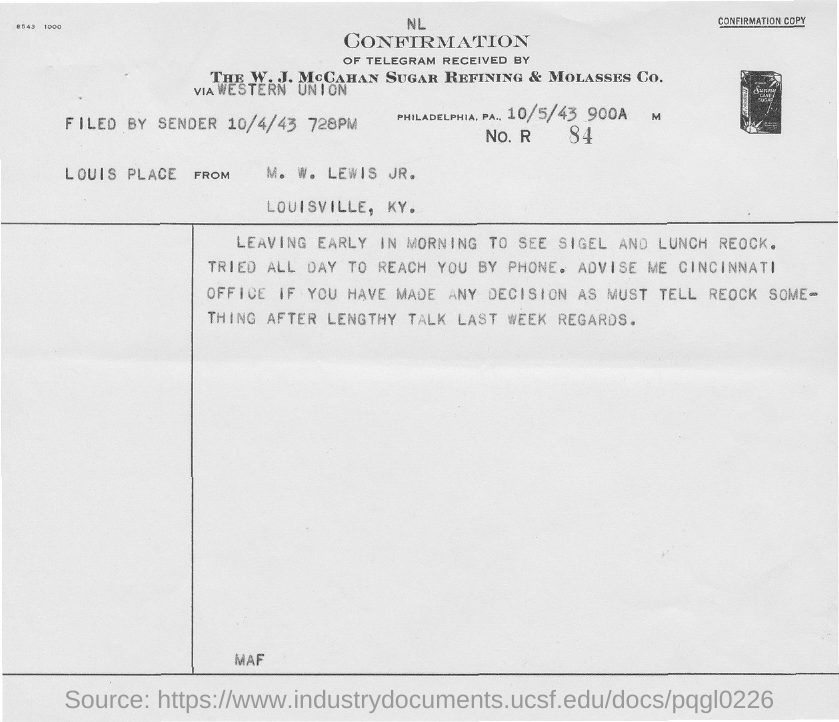When the sender filed the letter ?
Provide a succinct answer. 10/4/43. 